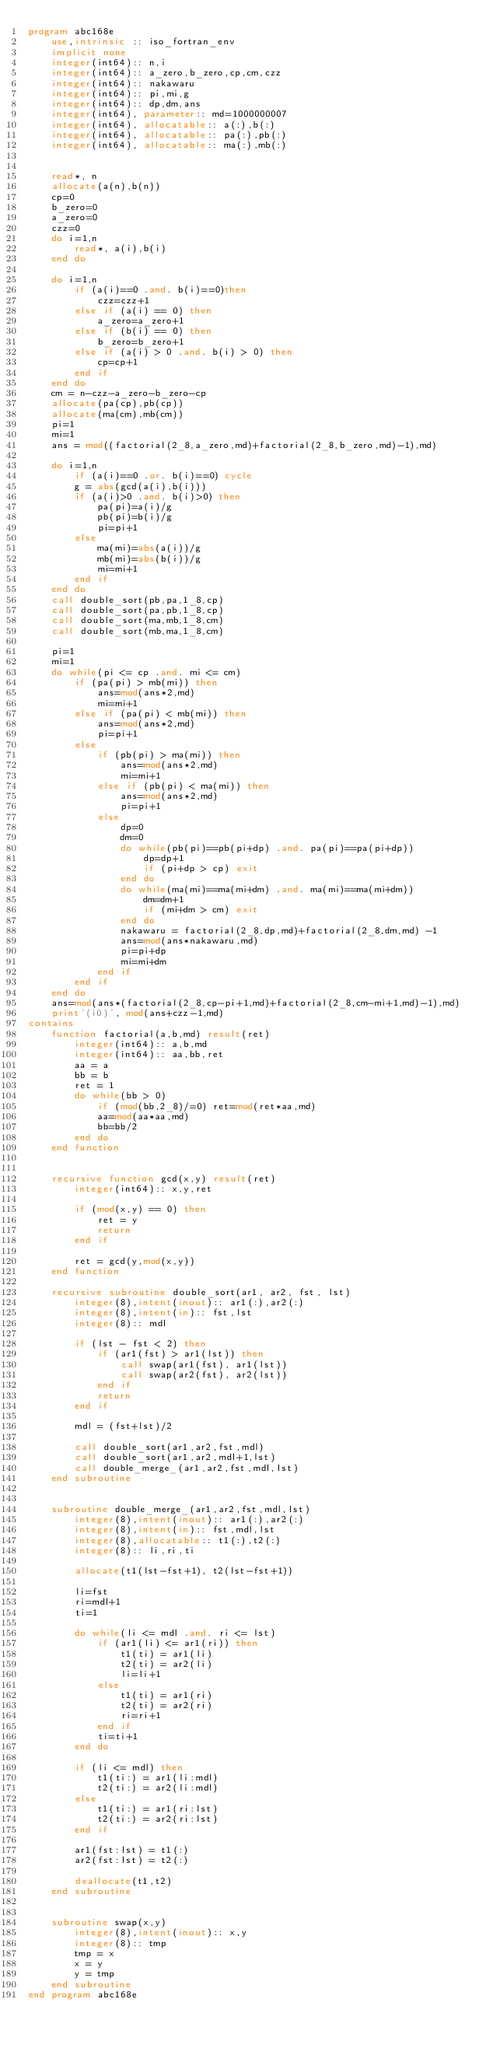Convert code to text. <code><loc_0><loc_0><loc_500><loc_500><_FORTRAN_>program abc168e
    use,intrinsic :: iso_fortran_env
    implicit none
    integer(int64):: n,i
    integer(int64):: a_zero,b_zero,cp,cm,czz
    integer(int64):: nakawaru
    integer(int64):: pi,mi,g
    integer(int64):: dp,dm,ans
    integer(int64), parameter:: md=1000000007
    integer(int64), allocatable:: a(:),b(:)
    integer(int64), allocatable:: pa(:),pb(:)
    integer(int64), allocatable:: ma(:),mb(:)


    read*, n
    allocate(a(n),b(n))
    cp=0
    b_zero=0
    a_zero=0
    czz=0
    do i=1,n
        read*, a(i),b(i)
    end do

    do i=1,n
        if (a(i)==0 .and. b(i)==0)then
            czz=czz+1
        else if (a(i) == 0) then
            a_zero=a_zero+1
        else if (b(i) == 0) then
            b_zero=b_zero+1
        else if (a(i) > 0 .and. b(i) > 0) then
            cp=cp+1
        end if
    end do
    cm = n-czz-a_zero-b_zero-cp
    allocate(pa(cp),pb(cp))
    allocate(ma(cm),mb(cm))
    pi=1
    mi=1
    ans = mod((factorial(2_8,a_zero,md)+factorial(2_8,b_zero,md)-1),md)
    
    do i=1,n
        if (a(i)==0 .or. b(i)==0) cycle
        g = abs(gcd(a(i),b(i)))
        if (a(i)>0 .and. b(i)>0) then
            pa(pi)=a(i)/g
            pb(pi)=b(i)/g
            pi=pi+1
        else
            ma(mi)=abs(a(i))/g
            mb(mi)=abs(b(i))/g
            mi=mi+1
        end if
    end do
    call double_sort(pb,pa,1_8,cp)
    call double_sort(pa,pb,1_8,cp)
    call double_sort(ma,mb,1_8,cm)
    call double_sort(mb,ma,1_8,cm)

    pi=1
    mi=1
    do while(pi <= cp .and. mi <= cm)
        if (pa(pi) > mb(mi)) then
            ans=mod(ans*2,md)
            mi=mi+1
        else if (pa(pi) < mb(mi)) then
            ans=mod(ans*2,md)
            pi=pi+1
        else
            if (pb(pi) > ma(mi)) then
                ans=mod(ans*2,md)
                mi=mi+1
            else if (pb(pi) < ma(mi)) then
                ans=mod(ans*2,md)
                pi=pi+1
            else
                dp=0
                dm=0
                do while(pb(pi)==pb(pi+dp) .and. pa(pi)==pa(pi+dp))
                    dp=dp+1
                    if (pi+dp > cp) exit
                end do
                do while(ma(mi)==ma(mi+dm) .and. ma(mi)==ma(mi+dm))
                    dm=dm+1
                    if (mi+dm > cm) exit
                end do
                nakawaru = factorial(2_8,dp,md)+factorial(2_8,dm,md) -1
                ans=mod(ans*nakawaru,md)
                pi=pi+dp
                mi=mi+dm
            end if
        end if
    end do
    ans=mod(ans*(factorial(2_8,cp-pi+1,md)+factorial(2_8,cm-mi+1,md)-1),md)
    print'(i0)', mod(ans+czz-1,md)
contains
    function factorial(a,b,md) result(ret)
        integer(int64):: a,b,md
        integer(int64):: aa,bb,ret
        aa = a
        bb = b
        ret = 1
        do while(bb > 0)
            if (mod(bb,2_8)/=0) ret=mod(ret*aa,md)
            aa=mod(aa*aa,md)
            bb=bb/2
        end do
    end function


    recursive function gcd(x,y) result(ret)
        integer(int64):: x,y,ret

        if (mod(x,y) == 0) then
            ret = y
            return
        end if

        ret = gcd(y,mod(x,y))
    end function

    recursive subroutine double_sort(ar1, ar2, fst, lst)
        integer(8),intent(inout):: ar1(:),ar2(:)
        integer(8),intent(in):: fst,lst
        integer(8):: mdl

        if (lst - fst < 2) then
            if (ar1(fst) > ar1(lst)) then
                call swap(ar1(fst), ar1(lst))
                call swap(ar2(fst), ar2(lst))
            end if
            return
        end if

        mdl = (fst+lst)/2

        call double_sort(ar1,ar2,fst,mdl)
        call double_sort(ar1,ar2,mdl+1,lst)
        call double_merge_(ar1,ar2,fst,mdl,lst)
    end subroutine


    subroutine double_merge_(ar1,ar2,fst,mdl,lst)
        integer(8),intent(inout):: ar1(:),ar2(:)
        integer(8),intent(in):: fst,mdl,lst
        integer(8),allocatable:: t1(:),t2(:)
        integer(8):: li,ri,ti

        allocate(t1(lst-fst+1), t2(lst-fst+1))

        li=fst
        ri=mdl+1
        ti=1

        do while(li <= mdl .and. ri <= lst)
            if (ar1(li) <= ar1(ri)) then
                t1(ti) = ar1(li) 
                t2(ti) = ar2(li)
                li=li+1
            else
                t1(ti) = ar1(ri)
                t2(ti) = ar2(ri)
                ri=ri+1
            end if
            ti=ti+1
        end do

        if (li <= mdl) then
            t1(ti:) = ar1(li:mdl)
            t2(ti:) = ar2(li:mdl)
        else
            t1(ti:) = ar1(ri:lst)
            t2(ti:) = ar2(ri:lst)
        end if

        ar1(fst:lst) = t1(:)
        ar2(fst:lst) = t2(:)

        deallocate(t1,t2)
    end subroutine

    
    subroutine swap(x,y)
        integer(8),intent(inout):: x,y
        integer(8):: tmp
        tmp = x
        x = y
        y = tmp
    end subroutine
end program abc168e</code> 